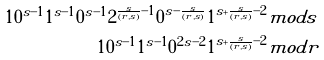<formula> <loc_0><loc_0><loc_500><loc_500>1 0 ^ { s - 1 } 1 ^ { s - 1 } 0 ^ { s - 1 } 2 ^ { \frac { s } { ( r , s ) } - 1 } 0 ^ { s - \frac { s } { ( r , s ) } } 1 ^ { s + \frac { s } { ( r , s ) } - 2 } & m o d s \\ 1 0 ^ { s - 1 } 1 ^ { s - 1 } 0 ^ { 2 s - 2 } 1 ^ { s + \frac { s } { ( r , s ) } - 2 } & m o d r</formula> 